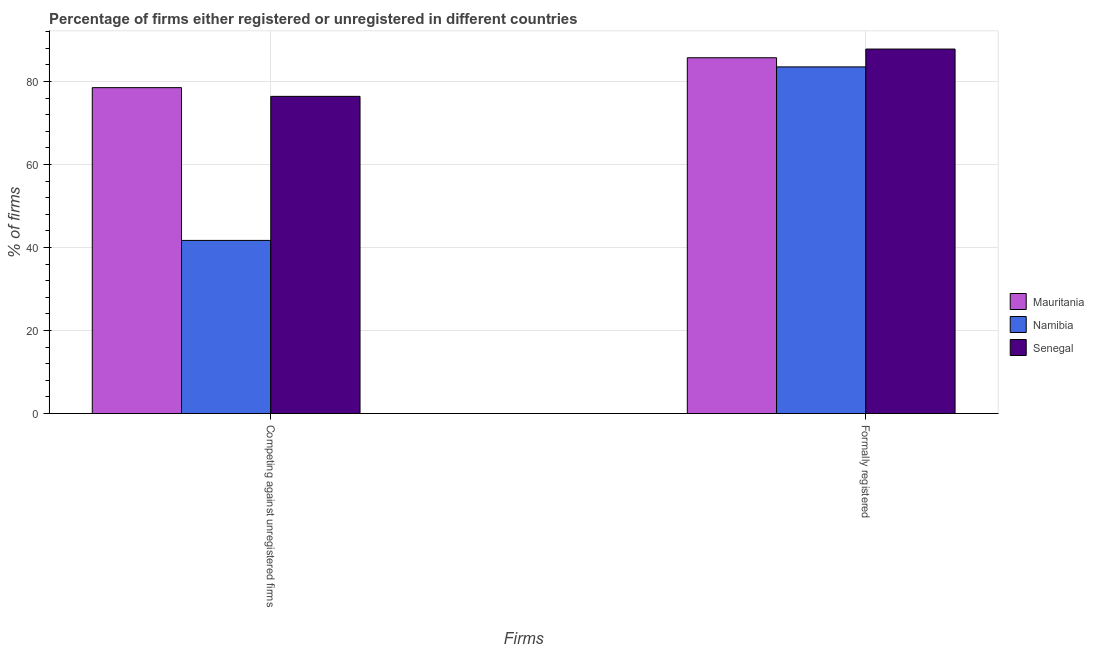How many groups of bars are there?
Give a very brief answer. 2. Are the number of bars on each tick of the X-axis equal?
Ensure brevity in your answer.  Yes. What is the label of the 1st group of bars from the left?
Provide a short and direct response. Competing against unregistered firms. What is the percentage of registered firms in Namibia?
Offer a very short reply. 41.7. Across all countries, what is the maximum percentage of registered firms?
Your answer should be very brief. 78.5. Across all countries, what is the minimum percentage of registered firms?
Your answer should be very brief. 41.7. In which country was the percentage of formally registered firms maximum?
Your response must be concise. Senegal. In which country was the percentage of formally registered firms minimum?
Ensure brevity in your answer.  Namibia. What is the total percentage of registered firms in the graph?
Offer a terse response. 196.6. What is the difference between the percentage of registered firms in Mauritania and that in Senegal?
Your response must be concise. 2.1. What is the difference between the percentage of formally registered firms in Mauritania and the percentage of registered firms in Namibia?
Your response must be concise. 44. What is the average percentage of formally registered firms per country?
Give a very brief answer. 85.67. What is the difference between the percentage of formally registered firms and percentage of registered firms in Mauritania?
Your answer should be very brief. 7.2. What is the ratio of the percentage of formally registered firms in Senegal to that in Namibia?
Keep it short and to the point. 1.05. Is the percentage of formally registered firms in Senegal less than that in Namibia?
Ensure brevity in your answer.  No. What does the 3rd bar from the left in Competing against unregistered firms represents?
Offer a very short reply. Senegal. What does the 1st bar from the right in Formally registered represents?
Offer a terse response. Senegal. How many bars are there?
Keep it short and to the point. 6. How many countries are there in the graph?
Offer a terse response. 3. What is the difference between two consecutive major ticks on the Y-axis?
Your response must be concise. 20. Are the values on the major ticks of Y-axis written in scientific E-notation?
Offer a very short reply. No. Does the graph contain grids?
Your answer should be compact. Yes. Where does the legend appear in the graph?
Make the answer very short. Center right. How many legend labels are there?
Provide a succinct answer. 3. What is the title of the graph?
Your response must be concise. Percentage of firms either registered or unregistered in different countries. Does "Italy" appear as one of the legend labels in the graph?
Your answer should be very brief. No. What is the label or title of the X-axis?
Provide a short and direct response. Firms. What is the label or title of the Y-axis?
Your answer should be very brief. % of firms. What is the % of firms in Mauritania in Competing against unregistered firms?
Your answer should be compact. 78.5. What is the % of firms of Namibia in Competing against unregistered firms?
Keep it short and to the point. 41.7. What is the % of firms in Senegal in Competing against unregistered firms?
Make the answer very short. 76.4. What is the % of firms of Mauritania in Formally registered?
Offer a terse response. 85.7. What is the % of firms of Namibia in Formally registered?
Provide a short and direct response. 83.5. What is the % of firms in Senegal in Formally registered?
Keep it short and to the point. 87.8. Across all Firms, what is the maximum % of firms in Mauritania?
Provide a succinct answer. 85.7. Across all Firms, what is the maximum % of firms in Namibia?
Your response must be concise. 83.5. Across all Firms, what is the maximum % of firms in Senegal?
Offer a terse response. 87.8. Across all Firms, what is the minimum % of firms of Mauritania?
Your answer should be compact. 78.5. Across all Firms, what is the minimum % of firms in Namibia?
Your response must be concise. 41.7. Across all Firms, what is the minimum % of firms in Senegal?
Offer a very short reply. 76.4. What is the total % of firms in Mauritania in the graph?
Your answer should be very brief. 164.2. What is the total % of firms in Namibia in the graph?
Your answer should be very brief. 125.2. What is the total % of firms of Senegal in the graph?
Your answer should be very brief. 164.2. What is the difference between the % of firms of Namibia in Competing against unregistered firms and that in Formally registered?
Provide a succinct answer. -41.8. What is the difference between the % of firms of Senegal in Competing against unregistered firms and that in Formally registered?
Make the answer very short. -11.4. What is the difference between the % of firms of Mauritania in Competing against unregistered firms and the % of firms of Senegal in Formally registered?
Keep it short and to the point. -9.3. What is the difference between the % of firms of Namibia in Competing against unregistered firms and the % of firms of Senegal in Formally registered?
Your answer should be compact. -46.1. What is the average % of firms in Mauritania per Firms?
Your answer should be compact. 82.1. What is the average % of firms in Namibia per Firms?
Ensure brevity in your answer.  62.6. What is the average % of firms in Senegal per Firms?
Make the answer very short. 82.1. What is the difference between the % of firms in Mauritania and % of firms in Namibia in Competing against unregistered firms?
Offer a very short reply. 36.8. What is the difference between the % of firms of Namibia and % of firms of Senegal in Competing against unregistered firms?
Your answer should be compact. -34.7. What is the difference between the % of firms of Mauritania and % of firms of Senegal in Formally registered?
Offer a very short reply. -2.1. What is the difference between the % of firms in Namibia and % of firms in Senegal in Formally registered?
Your answer should be very brief. -4.3. What is the ratio of the % of firms in Mauritania in Competing against unregistered firms to that in Formally registered?
Make the answer very short. 0.92. What is the ratio of the % of firms in Namibia in Competing against unregistered firms to that in Formally registered?
Give a very brief answer. 0.5. What is the ratio of the % of firms of Senegal in Competing against unregistered firms to that in Formally registered?
Provide a short and direct response. 0.87. What is the difference between the highest and the second highest % of firms in Mauritania?
Ensure brevity in your answer.  7.2. What is the difference between the highest and the second highest % of firms in Namibia?
Your response must be concise. 41.8. What is the difference between the highest and the lowest % of firms in Mauritania?
Provide a short and direct response. 7.2. What is the difference between the highest and the lowest % of firms in Namibia?
Give a very brief answer. 41.8. 